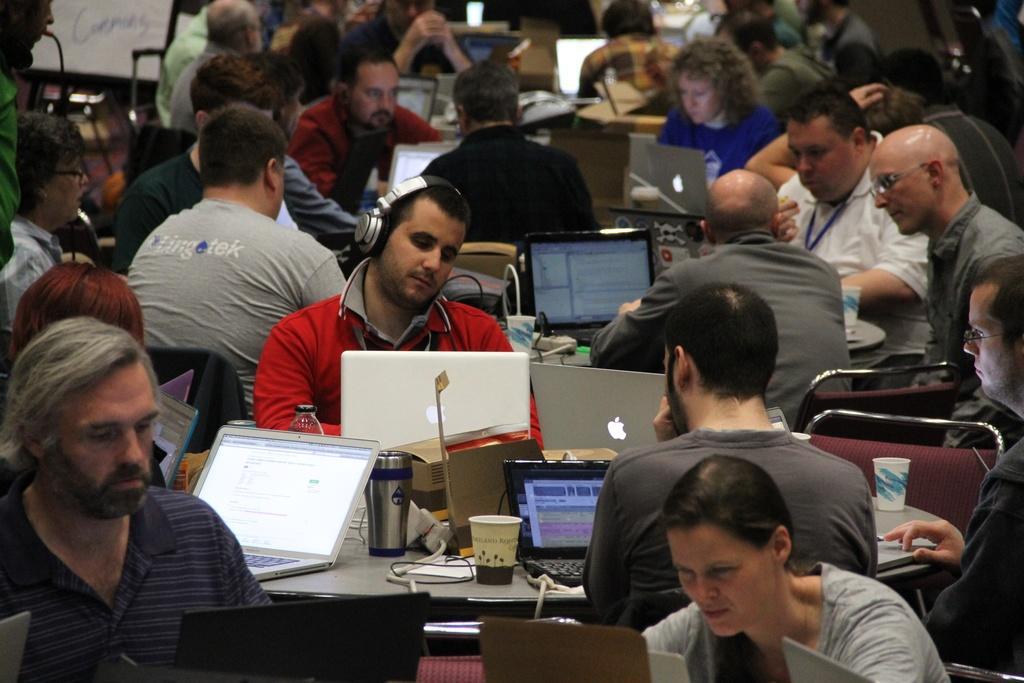In one or two sentences, can you explain what this image depicts? in this picture we can see all the persons sitting on chairs in front of a table and on the table we can see bottles, glasses, laptops. 